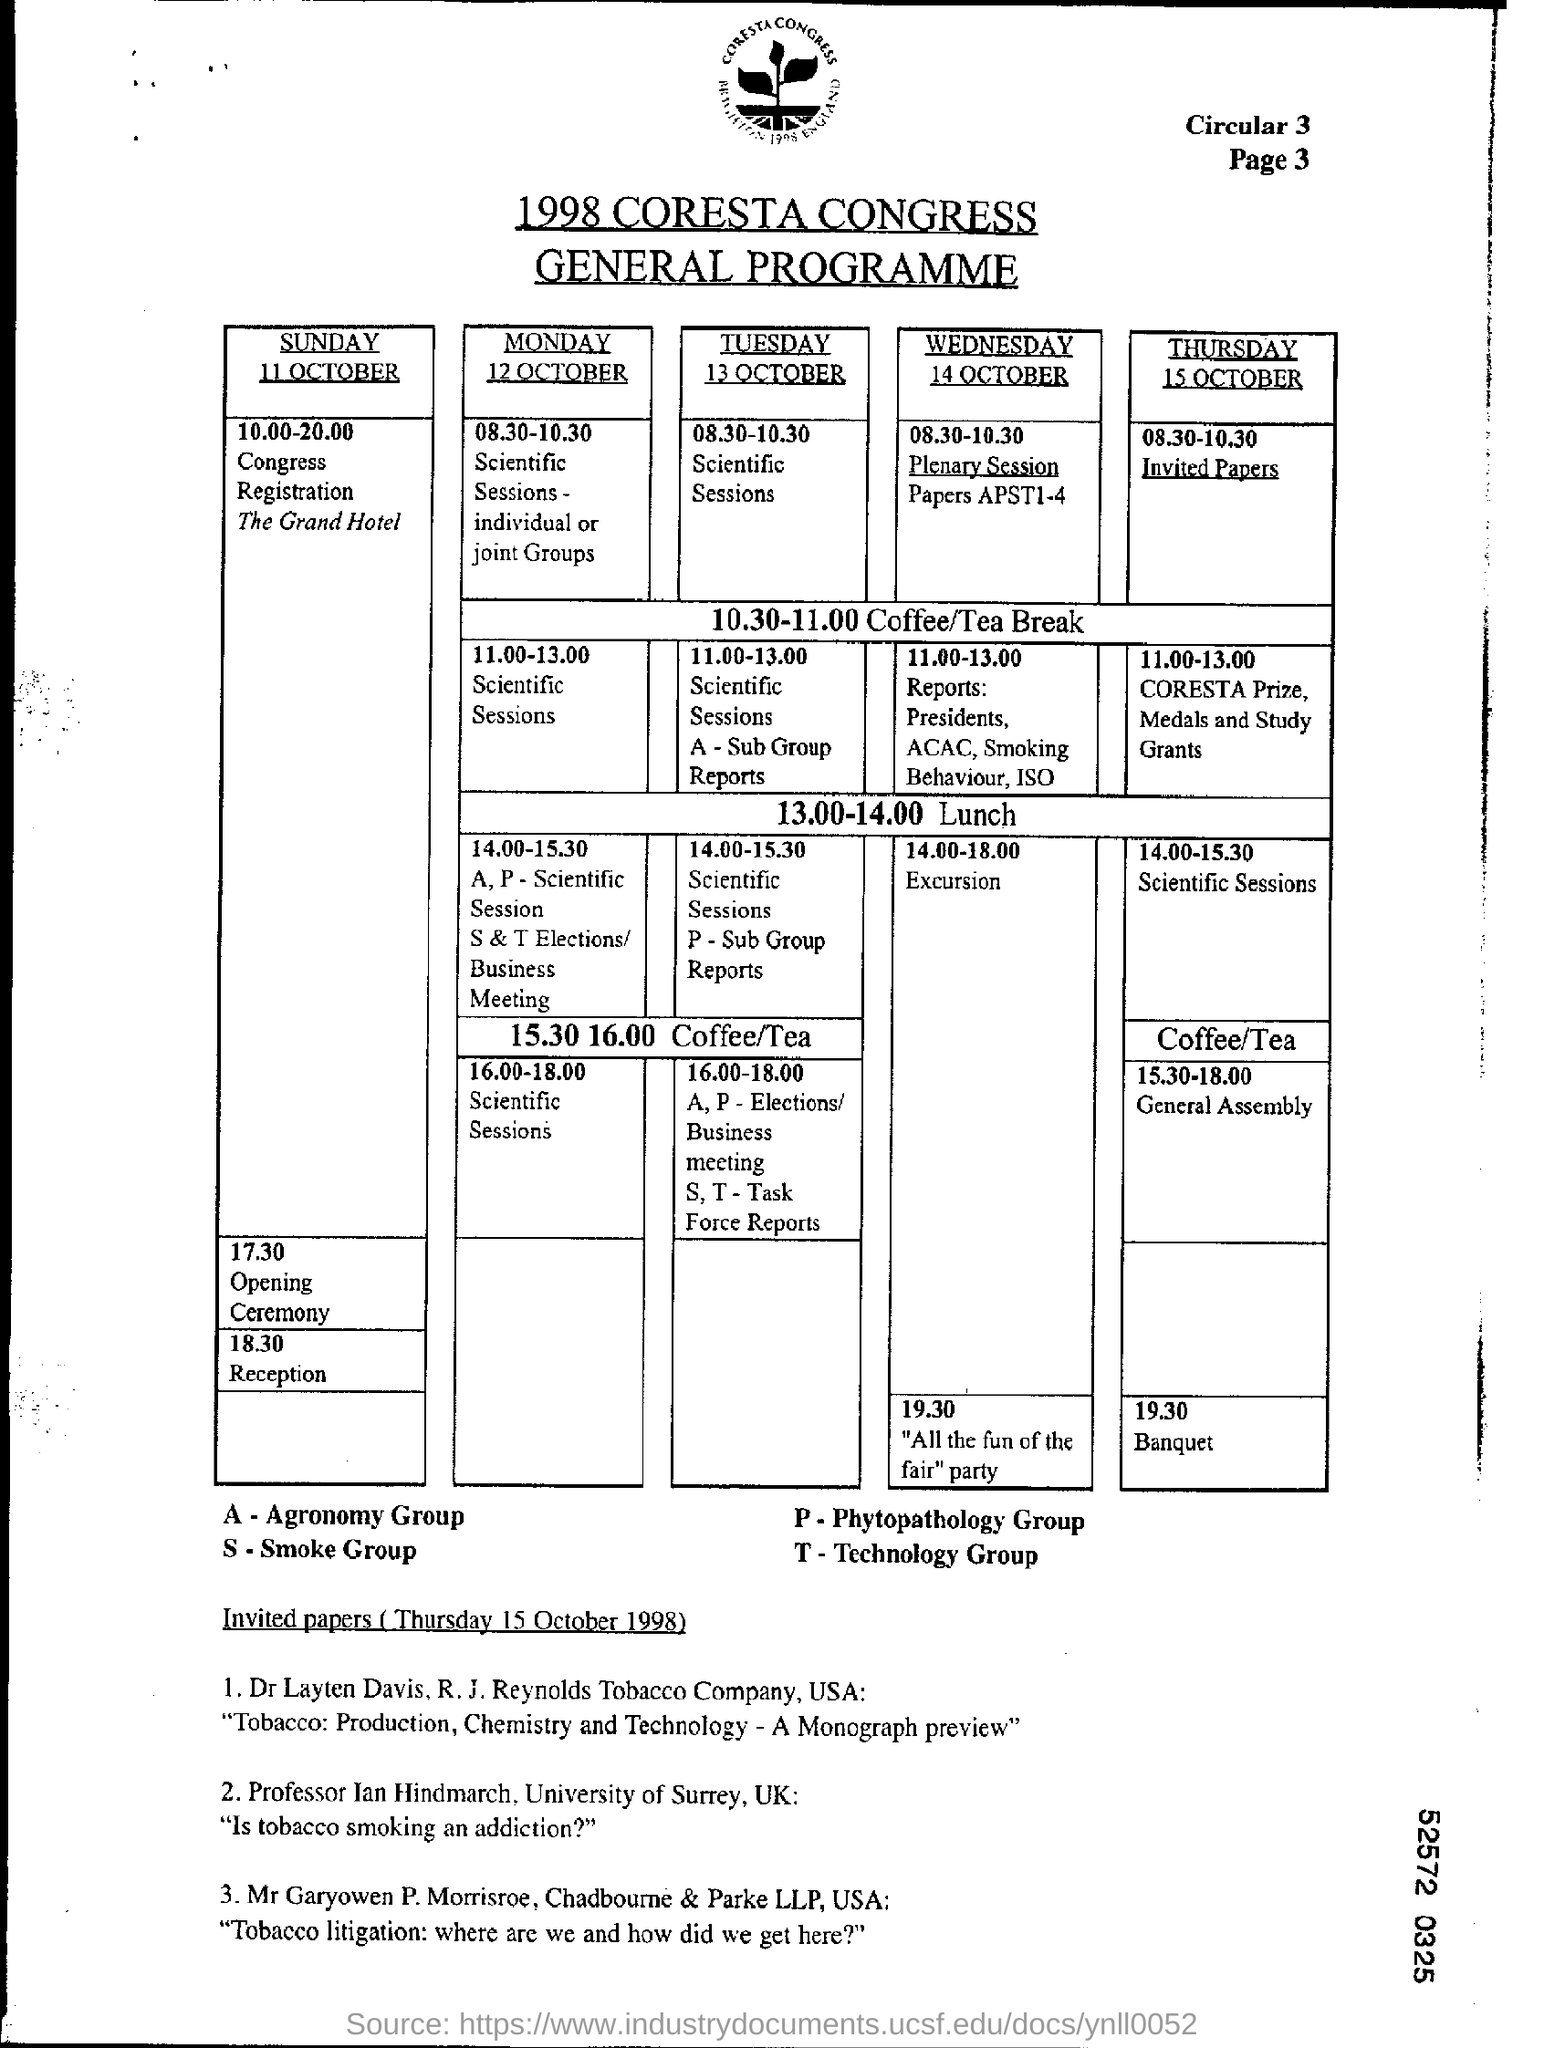What does "A" depict in the table?
Provide a short and direct response. Agronomy Group. What does "S" depict in the table?
Offer a very short reply. Smoke Group. What does "P" depict in the table?
Provide a succinct answer. Phytopathology Group. What does "T" depict in the table?
Make the answer very short. Technology Group. 